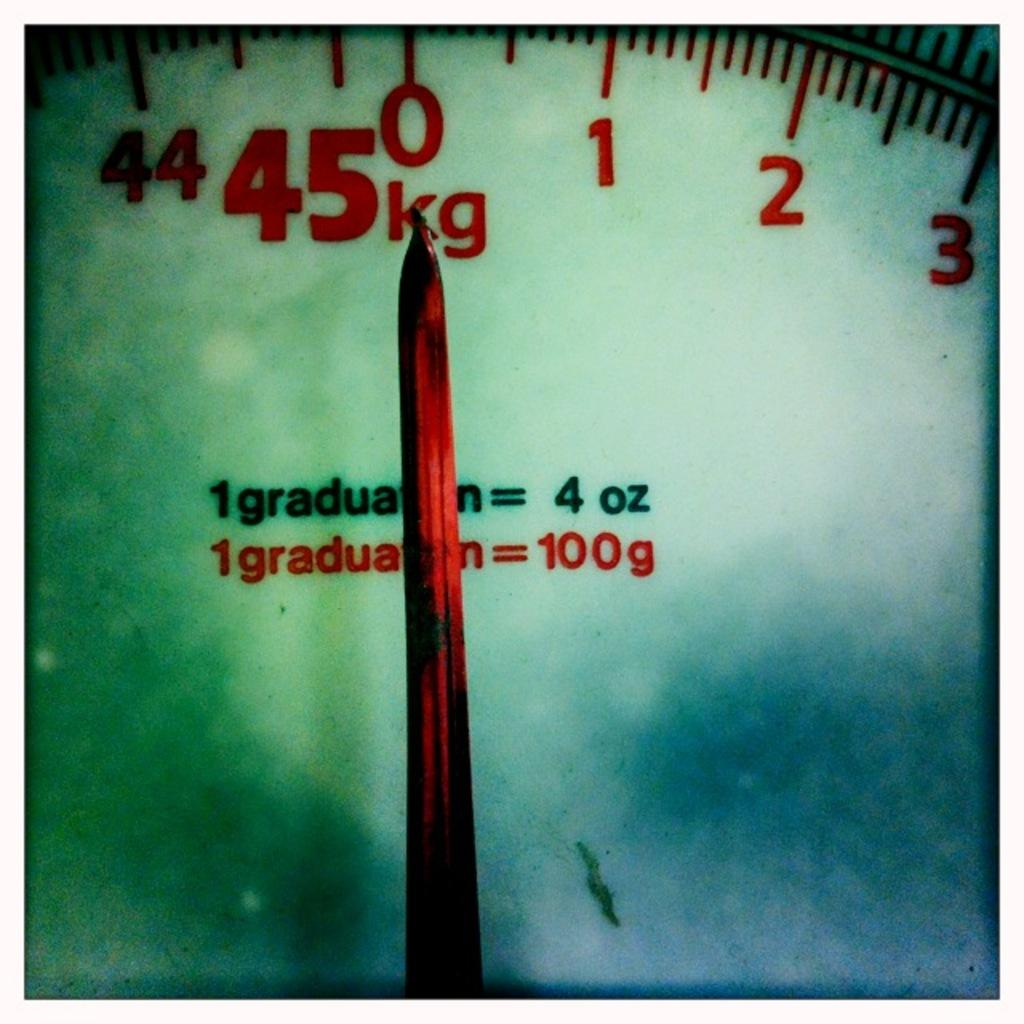<image>
Relay a brief, clear account of the picture shown. A scale's display shows that it can measure up to 45 kilograms. 